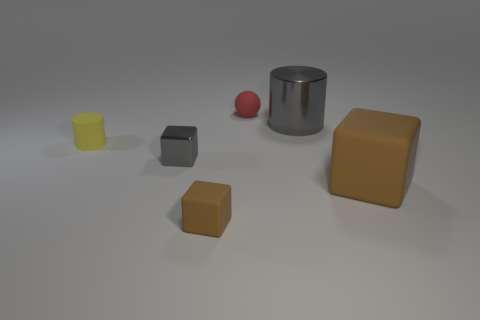Can you describe the lighting and mood of the scene? The image has a soft, diffused lighting that creates a tranquil and serene mood. The shadows are soft and the colors are muted, which gives the scene a sort of understated elegance. Could you infer anything about the setting where these objects are placed? The objects are placed on a surface with a neutral tone, and there's no distinct background, suggesting a controlled environment like a studio setup. This could also simulate a neutral space for product display or a 3D rendering test. 